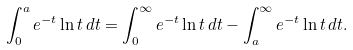<formula> <loc_0><loc_0><loc_500><loc_500>\int _ { 0 } ^ { a } e ^ { - t } \ln t \, d t = \int _ { 0 } ^ { \infty } e ^ { - t } \ln t \, d t - \int _ { a } ^ { \infty } e ^ { - t } \ln t \, d t .</formula> 